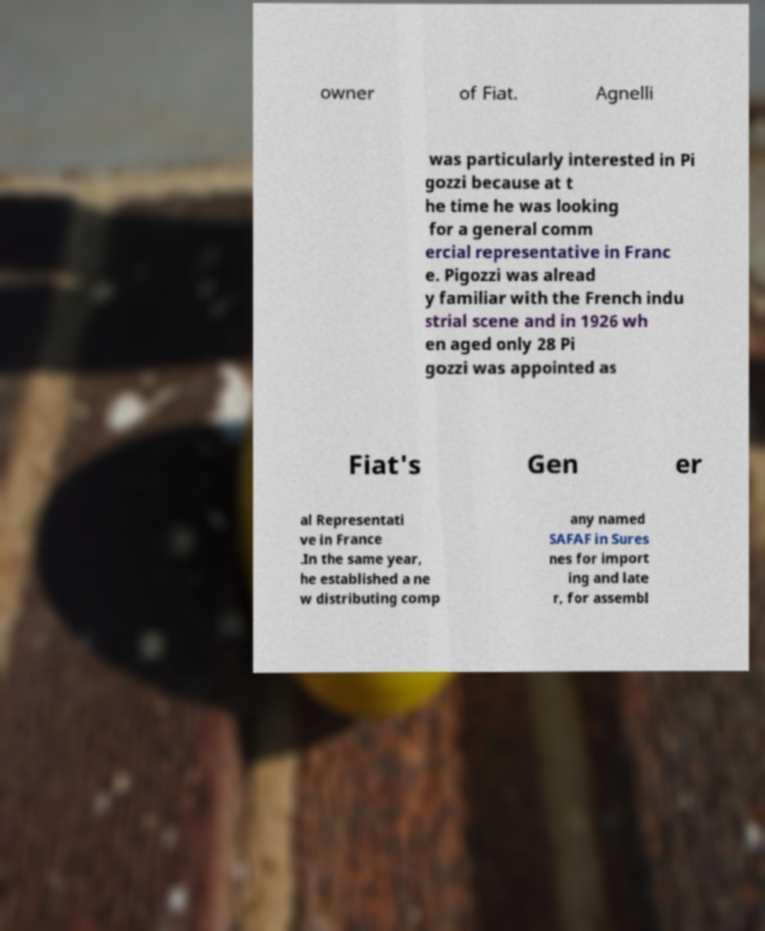I need the written content from this picture converted into text. Can you do that? owner of Fiat. Agnelli was particularly interested in Pi gozzi because at t he time he was looking for a general comm ercial representative in Franc e. Pigozzi was alread y familiar with the French indu strial scene and in 1926 wh en aged only 28 Pi gozzi was appointed as Fiat's Gen er al Representati ve in France .In the same year, he established a ne w distributing comp any named SAFAF in Sures nes for import ing and late r, for assembl 